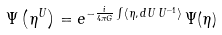<formula> <loc_0><loc_0><loc_500><loc_500>\Psi \left ( \eta ^ { U } \right ) = e ^ { - \frac { i } { 4 \pi G } \int \langle \eta , \, d U \, U ^ { - 1 } \rangle } \, \Psi ( \eta )</formula> 